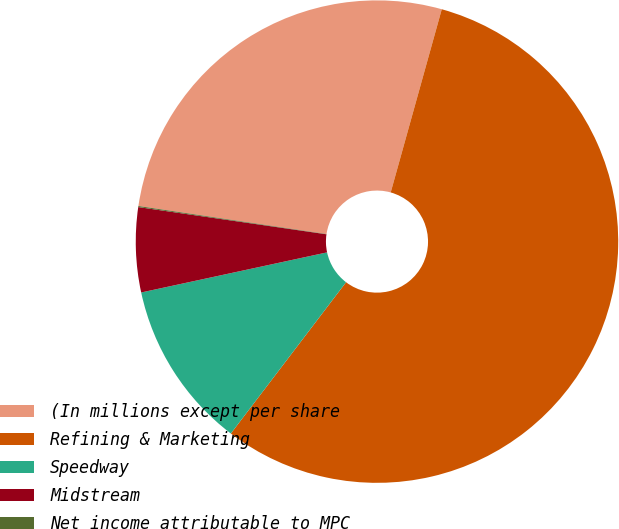Convert chart. <chart><loc_0><loc_0><loc_500><loc_500><pie_chart><fcel>(In millions except per share<fcel>Refining & Marketing<fcel>Speedway<fcel>Midstream<fcel>Net income attributable to MPC<nl><fcel>26.97%<fcel>56.03%<fcel>11.26%<fcel>5.67%<fcel>0.07%<nl></chart> 